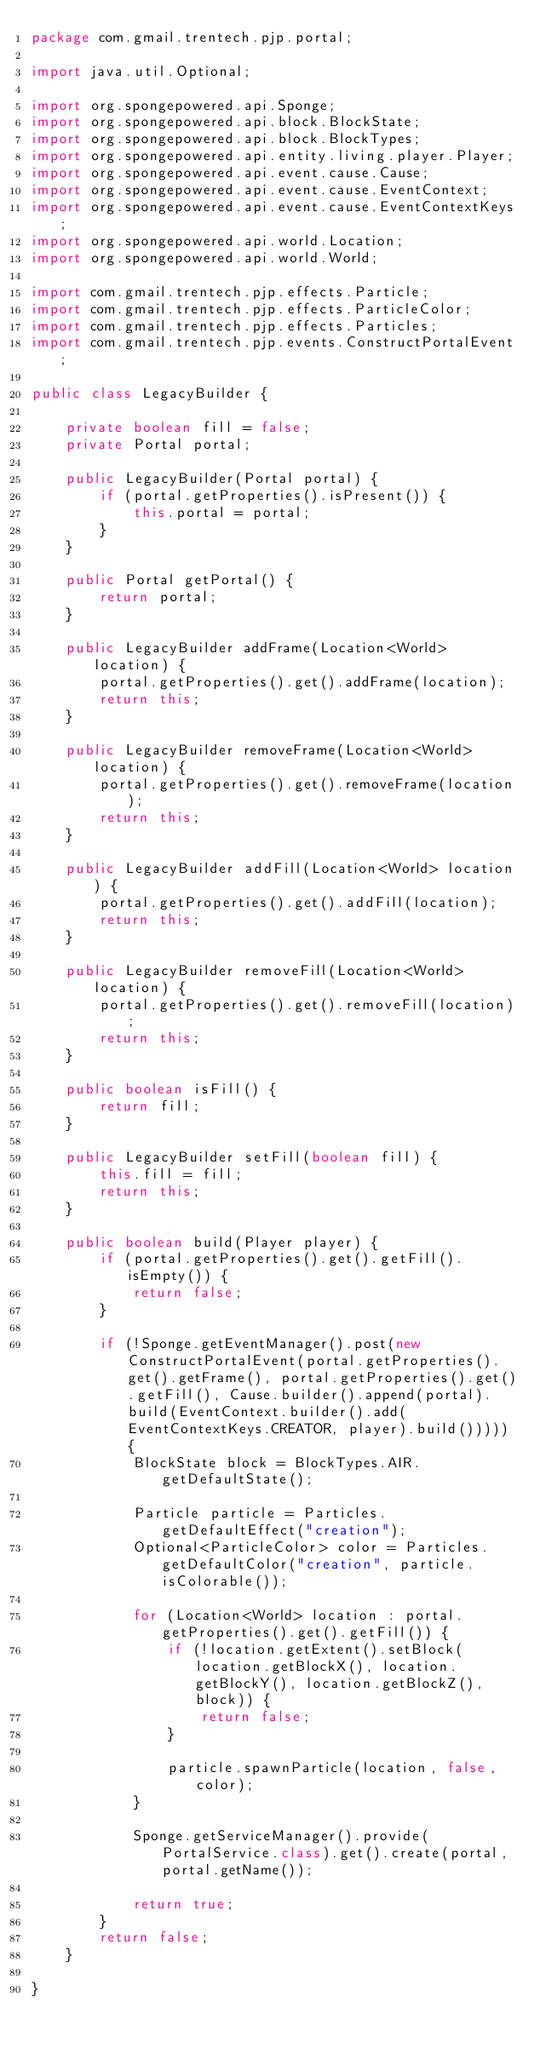Convert code to text. <code><loc_0><loc_0><loc_500><loc_500><_Java_>package com.gmail.trentech.pjp.portal;

import java.util.Optional;

import org.spongepowered.api.Sponge;
import org.spongepowered.api.block.BlockState;
import org.spongepowered.api.block.BlockTypes;
import org.spongepowered.api.entity.living.player.Player;
import org.spongepowered.api.event.cause.Cause;
import org.spongepowered.api.event.cause.EventContext;
import org.spongepowered.api.event.cause.EventContextKeys;
import org.spongepowered.api.world.Location;
import org.spongepowered.api.world.World;

import com.gmail.trentech.pjp.effects.Particle;
import com.gmail.trentech.pjp.effects.ParticleColor;
import com.gmail.trentech.pjp.effects.Particles;
import com.gmail.trentech.pjp.events.ConstructPortalEvent;

public class LegacyBuilder {

	private boolean fill = false;
	private Portal portal;

	public LegacyBuilder(Portal portal) {
		if (portal.getProperties().isPresent()) {
			this.portal = portal;
		}
	}

	public Portal getPortal() {
		return portal;
	}

	public LegacyBuilder addFrame(Location<World> location) {
		portal.getProperties().get().addFrame(location);
		return this;
	}

	public LegacyBuilder removeFrame(Location<World> location) {
		portal.getProperties().get().removeFrame(location);
		return this;
	}

	public LegacyBuilder addFill(Location<World> location) {
		portal.getProperties().get().addFill(location);
		return this;
	}

	public LegacyBuilder removeFill(Location<World> location) {
		portal.getProperties().get().removeFill(location);
		return this;
	}

	public boolean isFill() {
		return fill;
	}

	public LegacyBuilder setFill(boolean fill) {
		this.fill = fill;
		return this;
	}

	public boolean build(Player player) {
		if (portal.getProperties().get().getFill().isEmpty()) {
			return false;
		}

		if (!Sponge.getEventManager().post(new ConstructPortalEvent(portal.getProperties().get().getFrame(), portal.getProperties().get().getFill(), Cause.builder().append(portal).build(EventContext.builder().add(EventContextKeys.CREATOR, player).build())))) {
			BlockState block = BlockTypes.AIR.getDefaultState();

			Particle particle = Particles.getDefaultEffect("creation");
			Optional<ParticleColor> color = Particles.getDefaultColor("creation", particle.isColorable());

			for (Location<World> location : portal.getProperties().get().getFill()) {
				if (!location.getExtent().setBlock(location.getBlockX(), location.getBlockY(), location.getBlockZ(), block)) {
					return false;
				}

				particle.spawnParticle(location, false, color);
			}

			Sponge.getServiceManager().provide(PortalService.class).get().create(portal, portal.getName());

			return true;
		}
		return false;
	}

}
</code> 